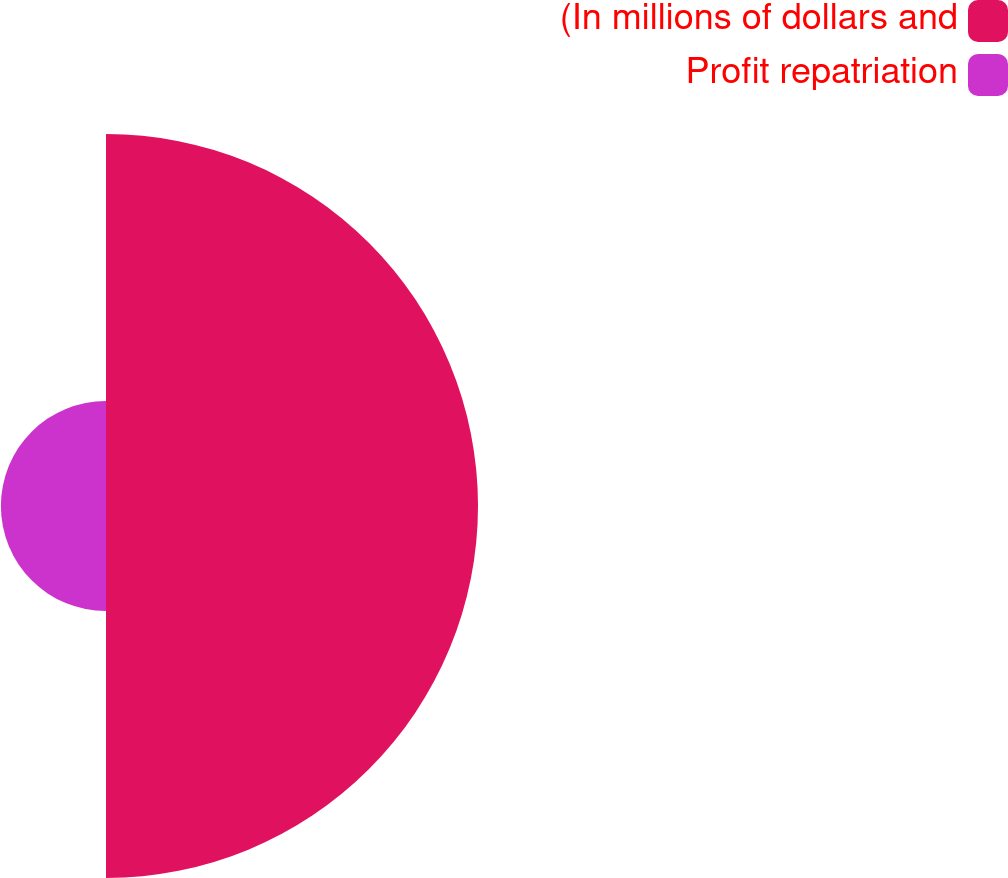Convert chart to OTSL. <chart><loc_0><loc_0><loc_500><loc_500><pie_chart><fcel>(In millions of dollars and<fcel>Profit repatriation<nl><fcel>77.97%<fcel>22.03%<nl></chart> 